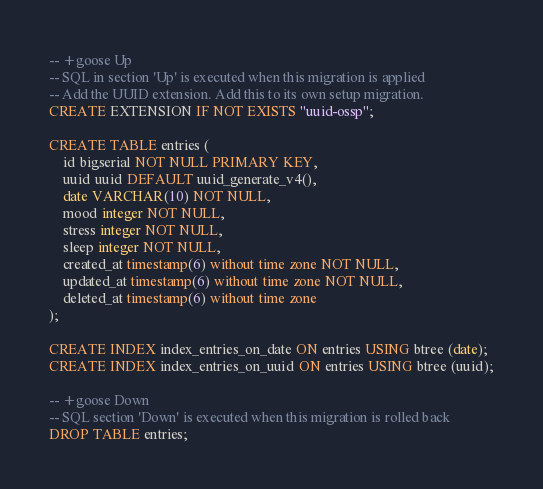<code> <loc_0><loc_0><loc_500><loc_500><_SQL_>-- +goose Up
-- SQL in section 'Up' is executed when this migration is applied
-- Add the UUID extension. Add this to its own setup migration.
CREATE EXTENSION IF NOT EXISTS "uuid-ossp";

CREATE TABLE entries (
    id bigserial NOT NULL PRIMARY KEY,
    uuid uuid DEFAULT uuid_generate_v4(),
    date VARCHAR(10) NOT NULL,
    mood integer NOT NULL,
    stress integer NOT NULL,
    sleep integer NOT NULL,
    created_at timestamp(6) without time zone NOT NULL,
    updated_at timestamp(6) without time zone NOT NULL,
    deleted_at timestamp(6) without time zone
);

CREATE INDEX index_entries_on_date ON entries USING btree (date);
CREATE INDEX index_entries_on_uuid ON entries USING btree (uuid);

-- +goose Down
-- SQL section 'Down' is executed when this migration is rolled back
DROP TABLE entries;
</code> 